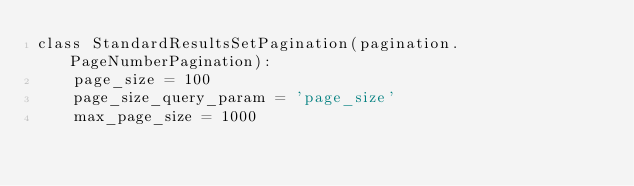<code> <loc_0><loc_0><loc_500><loc_500><_Python_>class StandardResultsSetPagination(pagination.PageNumberPagination):
    page_size = 100
    page_size_query_param = 'page_size'
    max_page_size = 1000</code> 